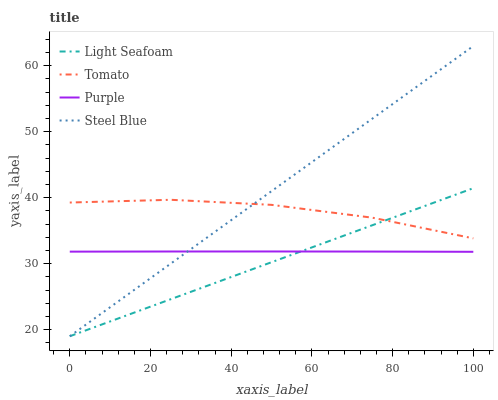Does Light Seafoam have the minimum area under the curve?
Answer yes or no. Yes. Does Steel Blue have the maximum area under the curve?
Answer yes or no. Yes. Does Purple have the minimum area under the curve?
Answer yes or no. No. Does Purple have the maximum area under the curve?
Answer yes or no. No. Is Light Seafoam the smoothest?
Answer yes or no. Yes. Is Tomato the roughest?
Answer yes or no. Yes. Is Purple the smoothest?
Answer yes or no. No. Is Purple the roughest?
Answer yes or no. No. Does Light Seafoam have the lowest value?
Answer yes or no. Yes. Does Purple have the lowest value?
Answer yes or no. No. Does Steel Blue have the highest value?
Answer yes or no. Yes. Does Light Seafoam have the highest value?
Answer yes or no. No. Is Purple less than Tomato?
Answer yes or no. Yes. Is Tomato greater than Purple?
Answer yes or no. Yes. Does Steel Blue intersect Light Seafoam?
Answer yes or no. Yes. Is Steel Blue less than Light Seafoam?
Answer yes or no. No. Is Steel Blue greater than Light Seafoam?
Answer yes or no. No. Does Purple intersect Tomato?
Answer yes or no. No. 